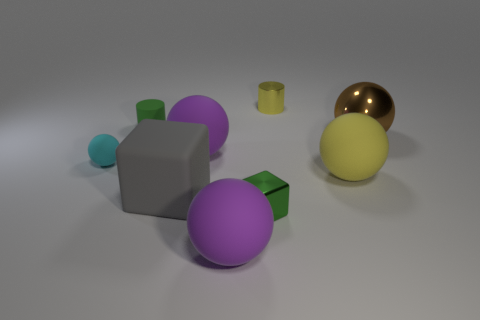There is a yellow object in front of the yellow shiny object; is its size the same as the large gray object?
Give a very brief answer. Yes. How many other objects are the same size as the yellow shiny cylinder?
Your answer should be very brief. 3. Are there any cyan matte spheres?
Provide a short and direct response. Yes. There is a cylinder on the left side of the big purple rubber object in front of the gray matte block; how big is it?
Offer a terse response. Small. There is a rubber ball right of the small cube; is it the same color as the small shiny thing that is to the left of the tiny yellow shiny thing?
Your response must be concise. No. There is a small thing that is both on the left side of the tiny yellow metal cylinder and behind the metal sphere; what is its color?
Keep it short and to the point. Green. How many other things are there of the same shape as the large yellow object?
Provide a succinct answer. 4. What is the color of the shiny object that is the same size as the rubber block?
Offer a very short reply. Brown. What is the color of the small matte sphere to the left of the large brown object?
Your answer should be compact. Cyan. There is a shiny thing to the right of the tiny metal cylinder; are there any big brown objects that are left of it?
Provide a short and direct response. No. 